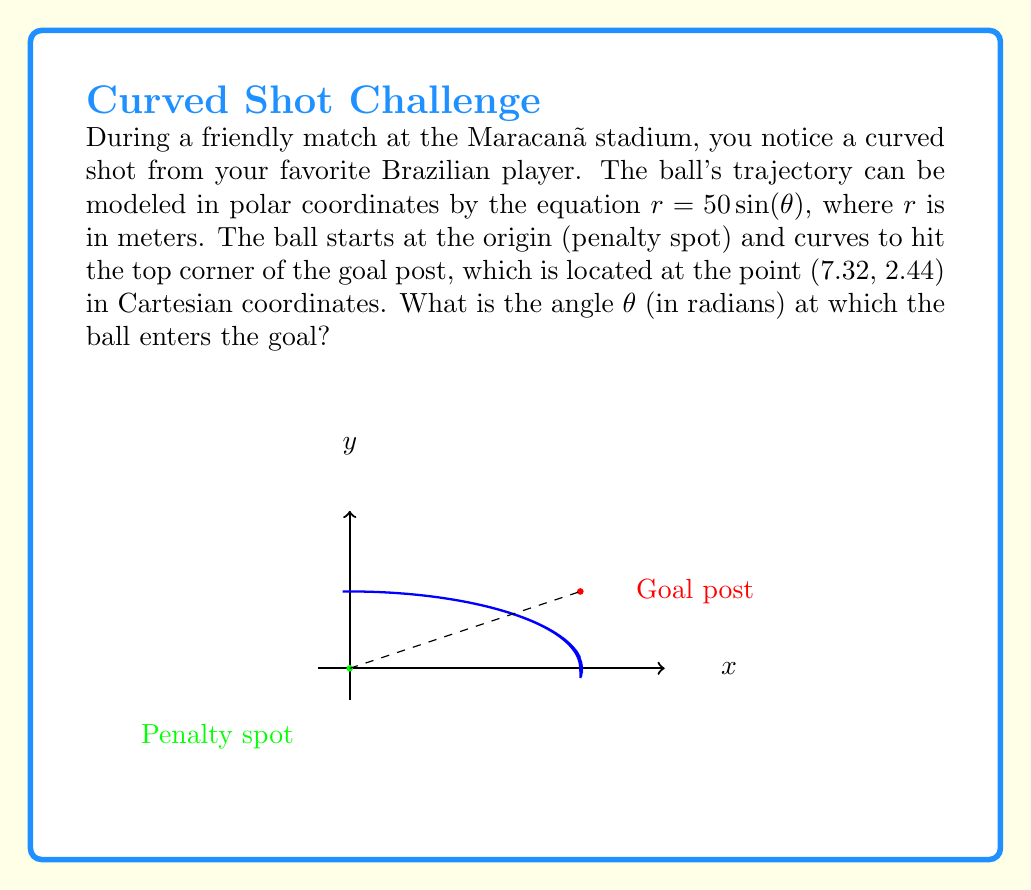Help me with this question. To solve this problem, we need to follow these steps:

1) First, we need to convert the Cartesian coordinates of the goal post (7.32, 2.44) to polar coordinates.

2) In polar form, $r^2 = x^2 + y^2$ and $\tan(\theta) = \frac{y}{x}$

3) Calculate $r$:
   $r = \sqrt{7.32^2 + 2.44^2} = \sqrt{59.7424} \approx 7.73$ meters

4) Calculate $\theta$:
   $\theta = \arctan(\frac{2.44}{7.32}) \approx 0.3217$ radians

5) Now we have the polar coordinates of the goal post: $(7.73, 0.3217)$

6) Recall that the trajectory equation is $r = 50\sin(\theta)$

7) Substitute the $r$ value we found:
   $7.73 = 50\sin(\theta)$

8) Solve for $\theta$:
   $\theta = \arcsin(\frac{7.73}{50}) \approx 0.1551$ radians

This is the angle at which the ball enters the goal.
Answer: $\theta \approx 0.1551$ radians 